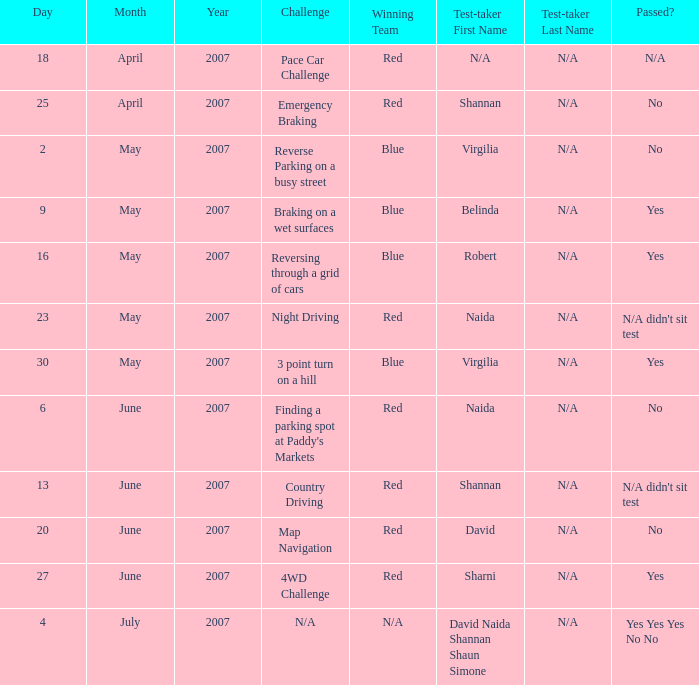What air date has a red winner and an emergency braking challenge? 25 April 2007. 